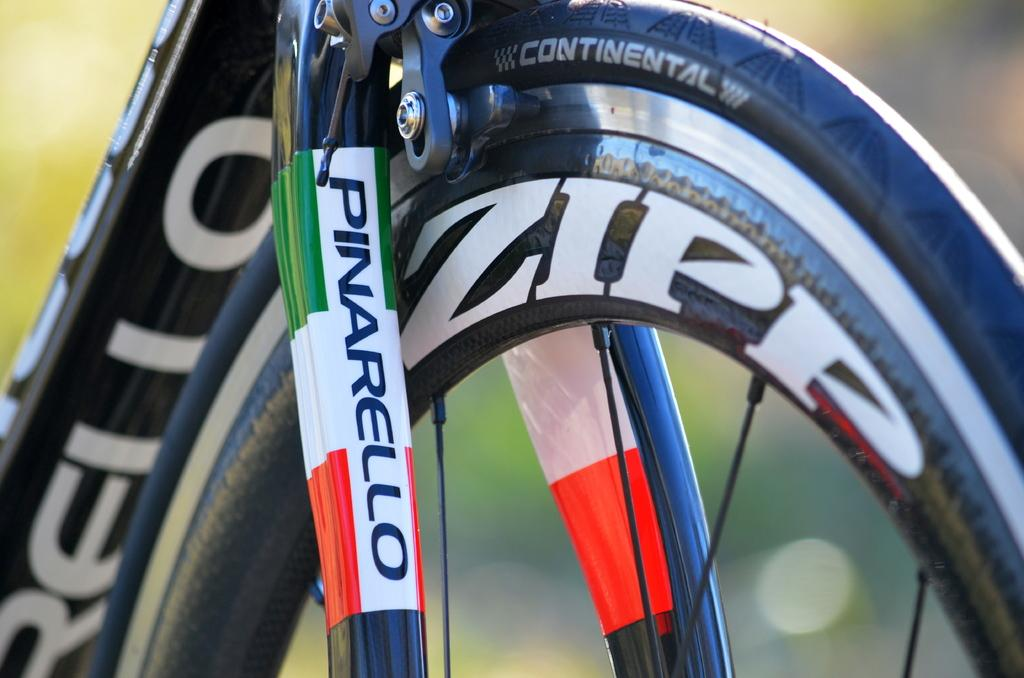What type of object is partially visible in the image? There is a part of a vehicle in the image. Can you read any text on the vehicle? Yes, there is text visible on the vehicle. How would you describe the background of the image? The background of the image is blurry. Is there a body of water visible in the image? No, there is no body of water visible in the image. What type of boundary can be seen in the image? There is no boundary present in the image. 